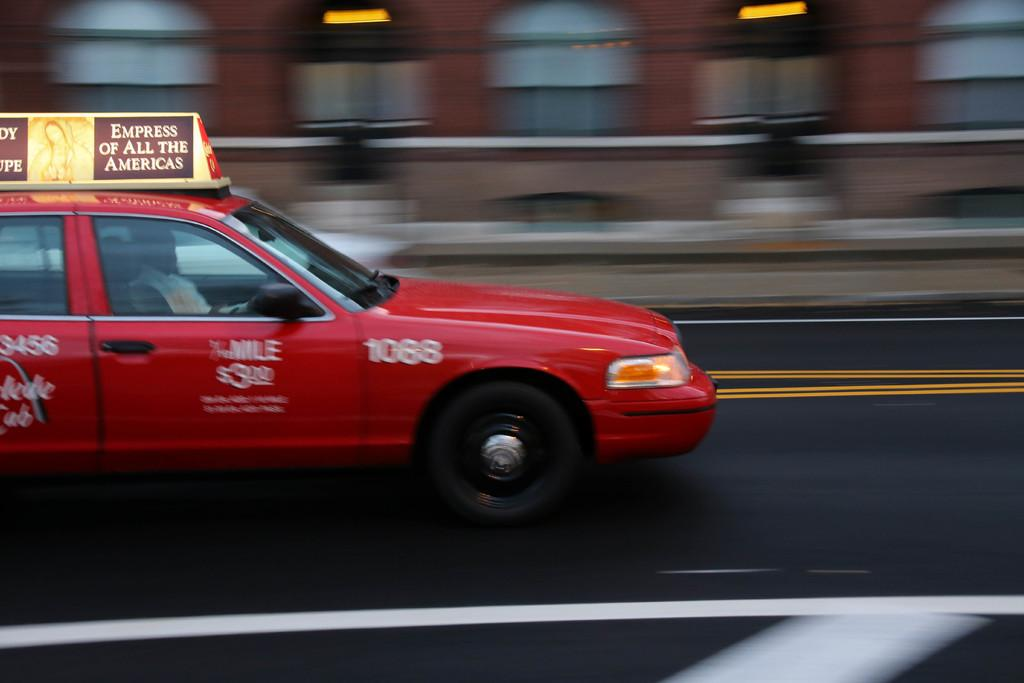Provide a one-sentence caption for the provided image. The number on the side of this red taxi is 1088. 